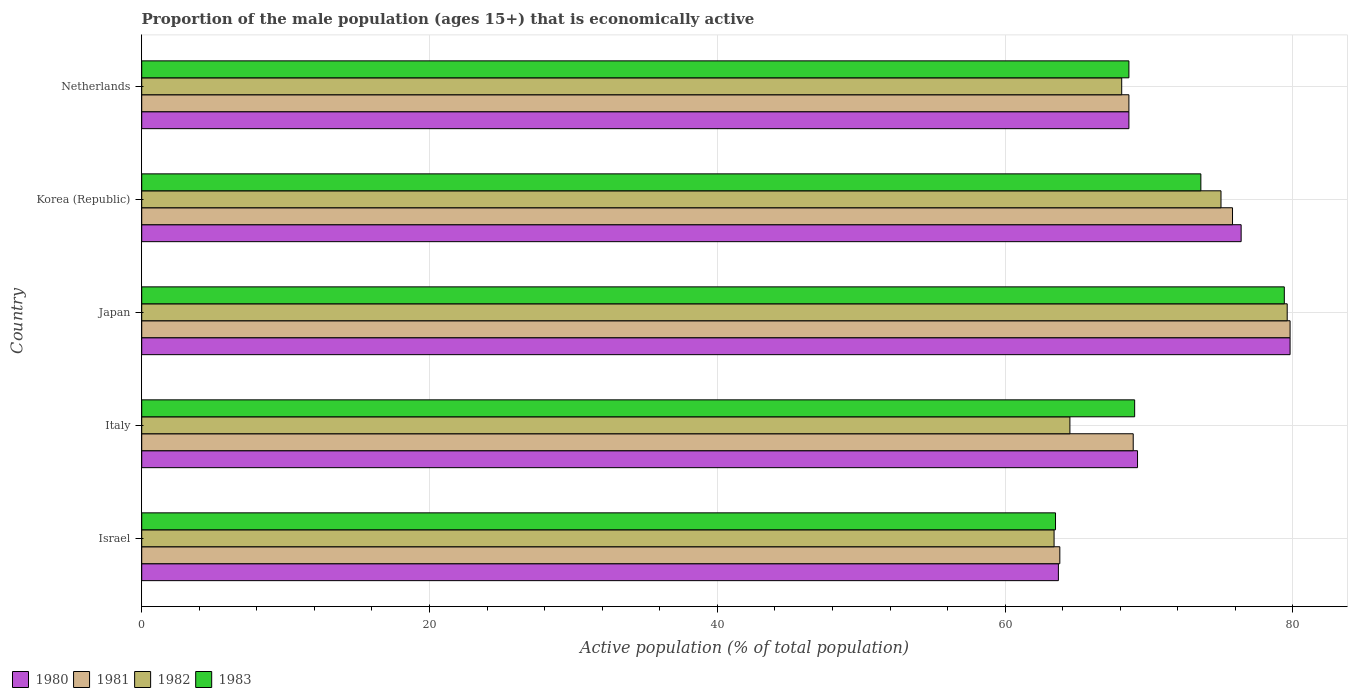How many different coloured bars are there?
Make the answer very short. 4. How many groups of bars are there?
Offer a terse response. 5. Are the number of bars on each tick of the Y-axis equal?
Offer a terse response. Yes. How many bars are there on the 3rd tick from the bottom?
Offer a very short reply. 4. What is the proportion of the male population that is economically active in 1983 in Italy?
Provide a succinct answer. 69. Across all countries, what is the maximum proportion of the male population that is economically active in 1980?
Ensure brevity in your answer.  79.8. Across all countries, what is the minimum proportion of the male population that is economically active in 1980?
Offer a very short reply. 63.7. In which country was the proportion of the male population that is economically active in 1983 minimum?
Offer a very short reply. Israel. What is the total proportion of the male population that is economically active in 1983 in the graph?
Make the answer very short. 354.1. What is the difference between the proportion of the male population that is economically active in 1983 in Japan and the proportion of the male population that is economically active in 1982 in Netherlands?
Your response must be concise. 11.3. What is the average proportion of the male population that is economically active in 1980 per country?
Keep it short and to the point. 71.54. What is the difference between the proportion of the male population that is economically active in 1981 and proportion of the male population that is economically active in 1983 in Israel?
Offer a very short reply. 0.3. In how many countries, is the proportion of the male population that is economically active in 1983 greater than 60 %?
Give a very brief answer. 5. What is the ratio of the proportion of the male population that is economically active in 1983 in Korea (Republic) to that in Netherlands?
Offer a terse response. 1.07. What is the difference between the highest and the second highest proportion of the male population that is economically active in 1980?
Give a very brief answer. 3.4. What is the difference between the highest and the lowest proportion of the male population that is economically active in 1983?
Ensure brevity in your answer.  15.9. Is the sum of the proportion of the male population that is economically active in 1982 in Israel and Italy greater than the maximum proportion of the male population that is economically active in 1983 across all countries?
Provide a succinct answer. Yes. Is it the case that in every country, the sum of the proportion of the male population that is economically active in 1982 and proportion of the male population that is economically active in 1981 is greater than the sum of proportion of the male population that is economically active in 1983 and proportion of the male population that is economically active in 1980?
Your answer should be very brief. No. What does the 4th bar from the top in Korea (Republic) represents?
Provide a succinct answer. 1980. Is it the case that in every country, the sum of the proportion of the male population that is economically active in 1980 and proportion of the male population that is economically active in 1982 is greater than the proportion of the male population that is economically active in 1981?
Keep it short and to the point. Yes. Are all the bars in the graph horizontal?
Give a very brief answer. Yes. How many countries are there in the graph?
Provide a short and direct response. 5. Does the graph contain grids?
Keep it short and to the point. Yes. Where does the legend appear in the graph?
Offer a terse response. Bottom left. How many legend labels are there?
Your answer should be compact. 4. How are the legend labels stacked?
Keep it short and to the point. Horizontal. What is the title of the graph?
Your response must be concise. Proportion of the male population (ages 15+) that is economically active. Does "2011" appear as one of the legend labels in the graph?
Keep it short and to the point. No. What is the label or title of the X-axis?
Keep it short and to the point. Active population (% of total population). What is the Active population (% of total population) in 1980 in Israel?
Provide a short and direct response. 63.7. What is the Active population (% of total population) of 1981 in Israel?
Ensure brevity in your answer.  63.8. What is the Active population (% of total population) in 1982 in Israel?
Offer a very short reply. 63.4. What is the Active population (% of total population) of 1983 in Israel?
Your answer should be compact. 63.5. What is the Active population (% of total population) of 1980 in Italy?
Offer a terse response. 69.2. What is the Active population (% of total population) in 1981 in Italy?
Your answer should be compact. 68.9. What is the Active population (% of total population) of 1982 in Italy?
Ensure brevity in your answer.  64.5. What is the Active population (% of total population) in 1983 in Italy?
Make the answer very short. 69. What is the Active population (% of total population) of 1980 in Japan?
Provide a short and direct response. 79.8. What is the Active population (% of total population) of 1981 in Japan?
Make the answer very short. 79.8. What is the Active population (% of total population) of 1982 in Japan?
Your answer should be very brief. 79.6. What is the Active population (% of total population) in 1983 in Japan?
Give a very brief answer. 79.4. What is the Active population (% of total population) of 1980 in Korea (Republic)?
Your answer should be compact. 76.4. What is the Active population (% of total population) of 1981 in Korea (Republic)?
Your answer should be compact. 75.8. What is the Active population (% of total population) of 1983 in Korea (Republic)?
Keep it short and to the point. 73.6. What is the Active population (% of total population) in 1980 in Netherlands?
Give a very brief answer. 68.6. What is the Active population (% of total population) of 1981 in Netherlands?
Offer a terse response. 68.6. What is the Active population (% of total population) of 1982 in Netherlands?
Offer a very short reply. 68.1. What is the Active population (% of total population) in 1983 in Netherlands?
Provide a short and direct response. 68.6. Across all countries, what is the maximum Active population (% of total population) of 1980?
Give a very brief answer. 79.8. Across all countries, what is the maximum Active population (% of total population) of 1981?
Offer a very short reply. 79.8. Across all countries, what is the maximum Active population (% of total population) of 1982?
Provide a succinct answer. 79.6. Across all countries, what is the maximum Active population (% of total population) in 1983?
Offer a terse response. 79.4. Across all countries, what is the minimum Active population (% of total population) in 1980?
Make the answer very short. 63.7. Across all countries, what is the minimum Active population (% of total population) in 1981?
Ensure brevity in your answer.  63.8. Across all countries, what is the minimum Active population (% of total population) in 1982?
Offer a very short reply. 63.4. Across all countries, what is the minimum Active population (% of total population) in 1983?
Keep it short and to the point. 63.5. What is the total Active population (% of total population) in 1980 in the graph?
Offer a terse response. 357.7. What is the total Active population (% of total population) in 1981 in the graph?
Provide a succinct answer. 356.9. What is the total Active population (% of total population) of 1982 in the graph?
Ensure brevity in your answer.  350.6. What is the total Active population (% of total population) in 1983 in the graph?
Your answer should be compact. 354.1. What is the difference between the Active population (% of total population) of 1980 in Israel and that in Italy?
Your response must be concise. -5.5. What is the difference between the Active population (% of total population) in 1983 in Israel and that in Italy?
Your response must be concise. -5.5. What is the difference between the Active population (% of total population) of 1980 in Israel and that in Japan?
Your answer should be compact. -16.1. What is the difference between the Active population (% of total population) in 1982 in Israel and that in Japan?
Make the answer very short. -16.2. What is the difference between the Active population (% of total population) in 1983 in Israel and that in Japan?
Your response must be concise. -15.9. What is the difference between the Active population (% of total population) of 1981 in Israel and that in Korea (Republic)?
Provide a short and direct response. -12. What is the difference between the Active population (% of total population) in 1980 in Israel and that in Netherlands?
Your answer should be very brief. -4.9. What is the difference between the Active population (% of total population) in 1981 in Israel and that in Netherlands?
Ensure brevity in your answer.  -4.8. What is the difference between the Active population (% of total population) in 1982 in Israel and that in Netherlands?
Give a very brief answer. -4.7. What is the difference between the Active population (% of total population) in 1983 in Israel and that in Netherlands?
Give a very brief answer. -5.1. What is the difference between the Active population (% of total population) in 1981 in Italy and that in Japan?
Your answer should be very brief. -10.9. What is the difference between the Active population (% of total population) in 1982 in Italy and that in Japan?
Your answer should be compact. -15.1. What is the difference between the Active population (% of total population) in 1980 in Italy and that in Korea (Republic)?
Offer a very short reply. -7.2. What is the difference between the Active population (% of total population) of 1980 in Italy and that in Netherlands?
Make the answer very short. 0.6. What is the difference between the Active population (% of total population) in 1981 in Italy and that in Netherlands?
Your answer should be compact. 0.3. What is the difference between the Active population (% of total population) in 1982 in Italy and that in Netherlands?
Your answer should be compact. -3.6. What is the difference between the Active population (% of total population) of 1980 in Japan and that in Korea (Republic)?
Offer a very short reply. 3.4. What is the difference between the Active population (% of total population) of 1982 in Japan and that in Korea (Republic)?
Your response must be concise. 4.6. What is the difference between the Active population (% of total population) of 1983 in Japan and that in Korea (Republic)?
Keep it short and to the point. 5.8. What is the difference between the Active population (% of total population) in 1980 in Japan and that in Netherlands?
Provide a short and direct response. 11.2. What is the difference between the Active population (% of total population) in 1982 in Japan and that in Netherlands?
Make the answer very short. 11.5. What is the difference between the Active population (% of total population) in 1981 in Korea (Republic) and that in Netherlands?
Provide a short and direct response. 7.2. What is the difference between the Active population (% of total population) in 1980 in Israel and the Active population (% of total population) in 1981 in Italy?
Provide a short and direct response. -5.2. What is the difference between the Active population (% of total population) of 1980 in Israel and the Active population (% of total population) of 1982 in Italy?
Offer a terse response. -0.8. What is the difference between the Active population (% of total population) of 1981 in Israel and the Active population (% of total population) of 1982 in Italy?
Your response must be concise. -0.7. What is the difference between the Active population (% of total population) of 1982 in Israel and the Active population (% of total population) of 1983 in Italy?
Provide a succinct answer. -5.6. What is the difference between the Active population (% of total population) in 1980 in Israel and the Active population (% of total population) in 1981 in Japan?
Provide a short and direct response. -16.1. What is the difference between the Active population (% of total population) of 1980 in Israel and the Active population (% of total population) of 1982 in Japan?
Offer a terse response. -15.9. What is the difference between the Active population (% of total population) of 1980 in Israel and the Active population (% of total population) of 1983 in Japan?
Provide a short and direct response. -15.7. What is the difference between the Active population (% of total population) of 1981 in Israel and the Active population (% of total population) of 1982 in Japan?
Ensure brevity in your answer.  -15.8. What is the difference between the Active population (% of total population) in 1981 in Israel and the Active population (% of total population) in 1983 in Japan?
Provide a succinct answer. -15.6. What is the difference between the Active population (% of total population) of 1982 in Israel and the Active population (% of total population) of 1983 in Japan?
Your response must be concise. -16. What is the difference between the Active population (% of total population) in 1980 in Israel and the Active population (% of total population) in 1981 in Korea (Republic)?
Your response must be concise. -12.1. What is the difference between the Active population (% of total population) of 1980 in Israel and the Active population (% of total population) of 1983 in Korea (Republic)?
Your answer should be compact. -9.9. What is the difference between the Active population (% of total population) in 1981 in Israel and the Active population (% of total population) in 1982 in Korea (Republic)?
Ensure brevity in your answer.  -11.2. What is the difference between the Active population (% of total population) of 1981 in Israel and the Active population (% of total population) of 1983 in Korea (Republic)?
Provide a succinct answer. -9.8. What is the difference between the Active population (% of total population) of 1982 in Israel and the Active population (% of total population) of 1983 in Korea (Republic)?
Your answer should be compact. -10.2. What is the difference between the Active population (% of total population) of 1980 in Israel and the Active population (% of total population) of 1981 in Netherlands?
Offer a very short reply. -4.9. What is the difference between the Active population (% of total population) in 1980 in Israel and the Active population (% of total population) in 1983 in Netherlands?
Your answer should be very brief. -4.9. What is the difference between the Active population (% of total population) of 1981 in Israel and the Active population (% of total population) of 1982 in Netherlands?
Offer a very short reply. -4.3. What is the difference between the Active population (% of total population) in 1981 in Israel and the Active population (% of total population) in 1983 in Netherlands?
Give a very brief answer. -4.8. What is the difference between the Active population (% of total population) of 1980 in Italy and the Active population (% of total population) of 1982 in Japan?
Provide a succinct answer. -10.4. What is the difference between the Active population (% of total population) in 1981 in Italy and the Active population (% of total population) in 1982 in Japan?
Provide a succinct answer. -10.7. What is the difference between the Active population (% of total population) of 1982 in Italy and the Active population (% of total population) of 1983 in Japan?
Offer a very short reply. -14.9. What is the difference between the Active population (% of total population) in 1980 in Italy and the Active population (% of total population) in 1982 in Korea (Republic)?
Offer a very short reply. -5.8. What is the difference between the Active population (% of total population) in 1981 in Italy and the Active population (% of total population) in 1982 in Korea (Republic)?
Your answer should be compact. -6.1. What is the difference between the Active population (% of total population) in 1980 in Italy and the Active population (% of total population) in 1982 in Netherlands?
Give a very brief answer. 1.1. What is the difference between the Active population (% of total population) of 1980 in Italy and the Active population (% of total population) of 1983 in Netherlands?
Provide a succinct answer. 0.6. What is the difference between the Active population (% of total population) of 1981 in Italy and the Active population (% of total population) of 1982 in Netherlands?
Your answer should be compact. 0.8. What is the difference between the Active population (% of total population) of 1981 in Italy and the Active population (% of total population) of 1983 in Netherlands?
Keep it short and to the point. 0.3. What is the difference between the Active population (% of total population) in 1981 in Japan and the Active population (% of total population) in 1982 in Korea (Republic)?
Keep it short and to the point. 4.8. What is the difference between the Active population (% of total population) in 1981 in Japan and the Active population (% of total population) in 1982 in Netherlands?
Keep it short and to the point. 11.7. What is the difference between the Active population (% of total population) in 1981 in Japan and the Active population (% of total population) in 1983 in Netherlands?
Keep it short and to the point. 11.2. What is the difference between the Active population (% of total population) in 1982 in Japan and the Active population (% of total population) in 1983 in Netherlands?
Ensure brevity in your answer.  11. What is the difference between the Active population (% of total population) in 1981 in Korea (Republic) and the Active population (% of total population) in 1982 in Netherlands?
Offer a terse response. 7.7. What is the average Active population (% of total population) in 1980 per country?
Your response must be concise. 71.54. What is the average Active population (% of total population) of 1981 per country?
Ensure brevity in your answer.  71.38. What is the average Active population (% of total population) of 1982 per country?
Your response must be concise. 70.12. What is the average Active population (% of total population) of 1983 per country?
Offer a very short reply. 70.82. What is the difference between the Active population (% of total population) of 1980 and Active population (% of total population) of 1981 in Israel?
Your response must be concise. -0.1. What is the difference between the Active population (% of total population) in 1980 and Active population (% of total population) in 1982 in Israel?
Provide a short and direct response. 0.3. What is the difference between the Active population (% of total population) of 1981 and Active population (% of total population) of 1983 in Israel?
Provide a short and direct response. 0.3. What is the difference between the Active population (% of total population) of 1982 and Active population (% of total population) of 1983 in Israel?
Keep it short and to the point. -0.1. What is the difference between the Active population (% of total population) in 1980 and Active population (% of total population) in 1982 in Italy?
Your answer should be compact. 4.7. What is the difference between the Active population (% of total population) of 1981 and Active population (% of total population) of 1983 in Japan?
Offer a very short reply. 0.4. What is the difference between the Active population (% of total population) in 1982 and Active population (% of total population) in 1983 in Japan?
Provide a short and direct response. 0.2. What is the difference between the Active population (% of total population) of 1980 and Active population (% of total population) of 1981 in Korea (Republic)?
Your answer should be compact. 0.6. What is the difference between the Active population (% of total population) of 1980 and Active population (% of total population) of 1982 in Netherlands?
Your answer should be very brief. 0.5. What is the difference between the Active population (% of total population) in 1980 and Active population (% of total population) in 1983 in Netherlands?
Give a very brief answer. 0. What is the difference between the Active population (% of total population) in 1982 and Active population (% of total population) in 1983 in Netherlands?
Keep it short and to the point. -0.5. What is the ratio of the Active population (% of total population) in 1980 in Israel to that in Italy?
Keep it short and to the point. 0.92. What is the ratio of the Active population (% of total population) of 1981 in Israel to that in Italy?
Keep it short and to the point. 0.93. What is the ratio of the Active population (% of total population) of 1982 in Israel to that in Italy?
Ensure brevity in your answer.  0.98. What is the ratio of the Active population (% of total population) of 1983 in Israel to that in Italy?
Your answer should be compact. 0.92. What is the ratio of the Active population (% of total population) of 1980 in Israel to that in Japan?
Make the answer very short. 0.8. What is the ratio of the Active population (% of total population) in 1981 in Israel to that in Japan?
Your answer should be very brief. 0.8. What is the ratio of the Active population (% of total population) in 1982 in Israel to that in Japan?
Offer a very short reply. 0.8. What is the ratio of the Active population (% of total population) of 1983 in Israel to that in Japan?
Your answer should be very brief. 0.8. What is the ratio of the Active population (% of total population) of 1980 in Israel to that in Korea (Republic)?
Ensure brevity in your answer.  0.83. What is the ratio of the Active population (% of total population) of 1981 in Israel to that in Korea (Republic)?
Offer a very short reply. 0.84. What is the ratio of the Active population (% of total population) of 1982 in Israel to that in Korea (Republic)?
Provide a short and direct response. 0.85. What is the ratio of the Active population (% of total population) in 1983 in Israel to that in Korea (Republic)?
Offer a very short reply. 0.86. What is the ratio of the Active population (% of total population) in 1980 in Israel to that in Netherlands?
Offer a terse response. 0.93. What is the ratio of the Active population (% of total population) in 1981 in Israel to that in Netherlands?
Your response must be concise. 0.93. What is the ratio of the Active population (% of total population) of 1982 in Israel to that in Netherlands?
Offer a very short reply. 0.93. What is the ratio of the Active population (% of total population) in 1983 in Israel to that in Netherlands?
Ensure brevity in your answer.  0.93. What is the ratio of the Active population (% of total population) of 1980 in Italy to that in Japan?
Your answer should be compact. 0.87. What is the ratio of the Active population (% of total population) of 1981 in Italy to that in Japan?
Keep it short and to the point. 0.86. What is the ratio of the Active population (% of total population) of 1982 in Italy to that in Japan?
Offer a very short reply. 0.81. What is the ratio of the Active population (% of total population) in 1983 in Italy to that in Japan?
Give a very brief answer. 0.87. What is the ratio of the Active population (% of total population) in 1980 in Italy to that in Korea (Republic)?
Make the answer very short. 0.91. What is the ratio of the Active population (% of total population) of 1981 in Italy to that in Korea (Republic)?
Offer a terse response. 0.91. What is the ratio of the Active population (% of total population) in 1982 in Italy to that in Korea (Republic)?
Offer a very short reply. 0.86. What is the ratio of the Active population (% of total population) in 1980 in Italy to that in Netherlands?
Ensure brevity in your answer.  1.01. What is the ratio of the Active population (% of total population) in 1981 in Italy to that in Netherlands?
Keep it short and to the point. 1. What is the ratio of the Active population (% of total population) of 1982 in Italy to that in Netherlands?
Provide a succinct answer. 0.95. What is the ratio of the Active population (% of total population) in 1980 in Japan to that in Korea (Republic)?
Provide a short and direct response. 1.04. What is the ratio of the Active population (% of total population) of 1981 in Japan to that in Korea (Republic)?
Provide a succinct answer. 1.05. What is the ratio of the Active population (% of total population) of 1982 in Japan to that in Korea (Republic)?
Your response must be concise. 1.06. What is the ratio of the Active population (% of total population) of 1983 in Japan to that in Korea (Republic)?
Your response must be concise. 1.08. What is the ratio of the Active population (% of total population) of 1980 in Japan to that in Netherlands?
Give a very brief answer. 1.16. What is the ratio of the Active population (% of total population) of 1981 in Japan to that in Netherlands?
Your answer should be compact. 1.16. What is the ratio of the Active population (% of total population) in 1982 in Japan to that in Netherlands?
Ensure brevity in your answer.  1.17. What is the ratio of the Active population (% of total population) in 1983 in Japan to that in Netherlands?
Keep it short and to the point. 1.16. What is the ratio of the Active population (% of total population) in 1980 in Korea (Republic) to that in Netherlands?
Give a very brief answer. 1.11. What is the ratio of the Active population (% of total population) of 1981 in Korea (Republic) to that in Netherlands?
Provide a succinct answer. 1.1. What is the ratio of the Active population (% of total population) of 1982 in Korea (Republic) to that in Netherlands?
Your answer should be compact. 1.1. What is the ratio of the Active population (% of total population) of 1983 in Korea (Republic) to that in Netherlands?
Your answer should be compact. 1.07. What is the difference between the highest and the second highest Active population (% of total population) in 1982?
Provide a short and direct response. 4.6. What is the difference between the highest and the second highest Active population (% of total population) of 1983?
Keep it short and to the point. 5.8. What is the difference between the highest and the lowest Active population (% of total population) in 1981?
Ensure brevity in your answer.  16. 